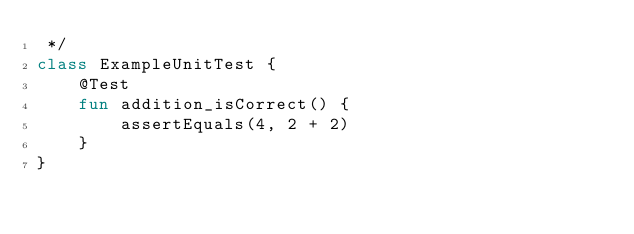<code> <loc_0><loc_0><loc_500><loc_500><_Kotlin_> */
class ExampleUnitTest {
    @Test
    fun addition_isCorrect() {
        assertEquals(4, 2 + 2)
    }
}</code> 